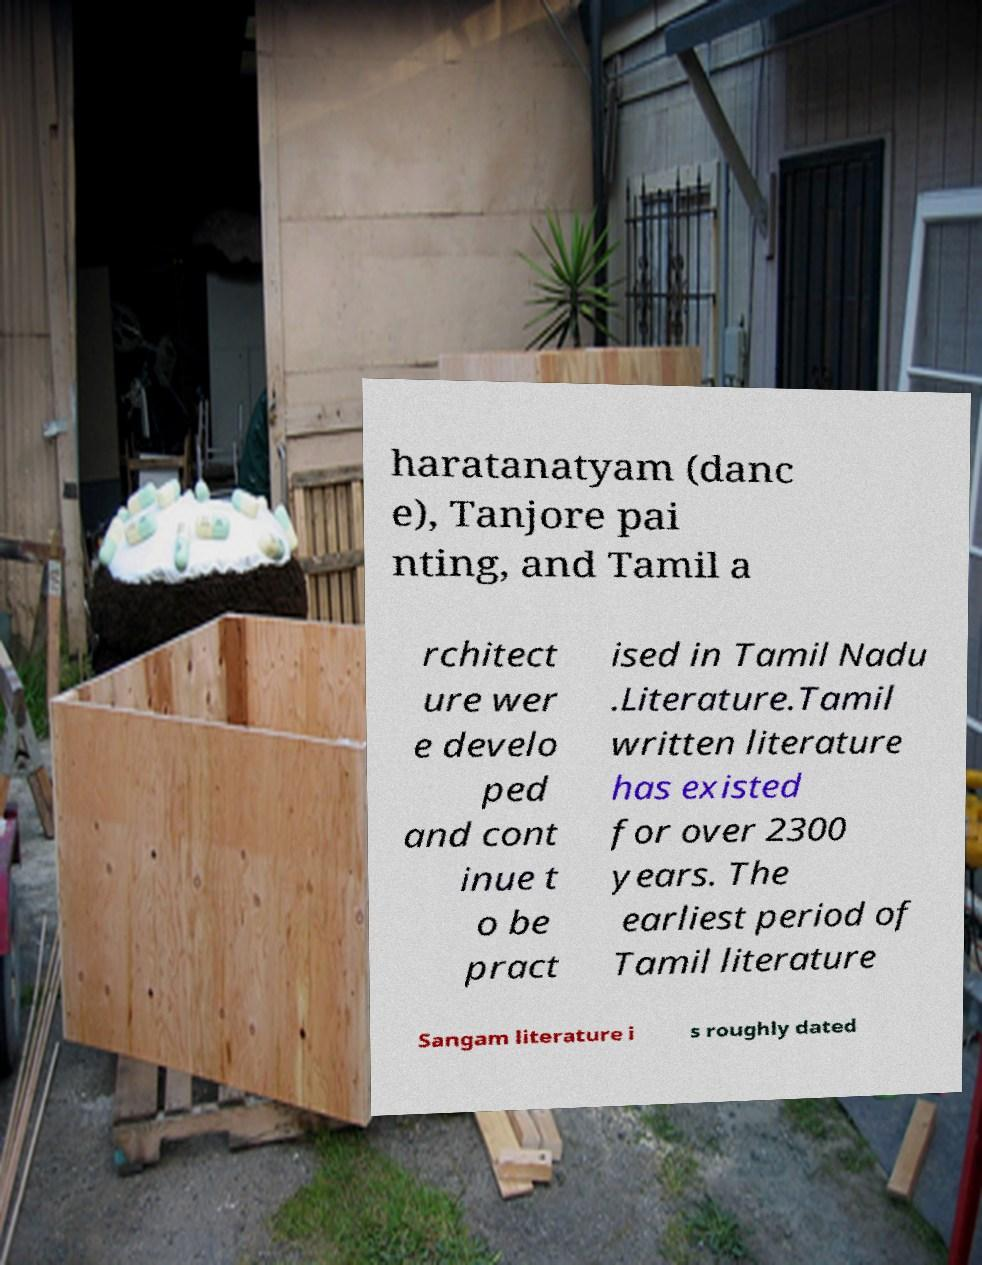Could you assist in decoding the text presented in this image and type it out clearly? haratanatyam (danc e), Tanjore pai nting, and Tamil a rchitect ure wer e develo ped and cont inue t o be pract ised in Tamil Nadu .Literature.Tamil written literature has existed for over 2300 years. The earliest period of Tamil literature Sangam literature i s roughly dated 